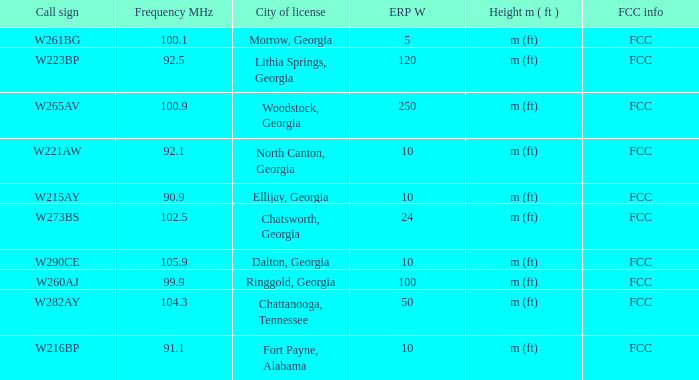Which City of license has a Frequency MHz smaller than 100.9, and a ERP W larger than 100? Lithia Springs, Georgia. 